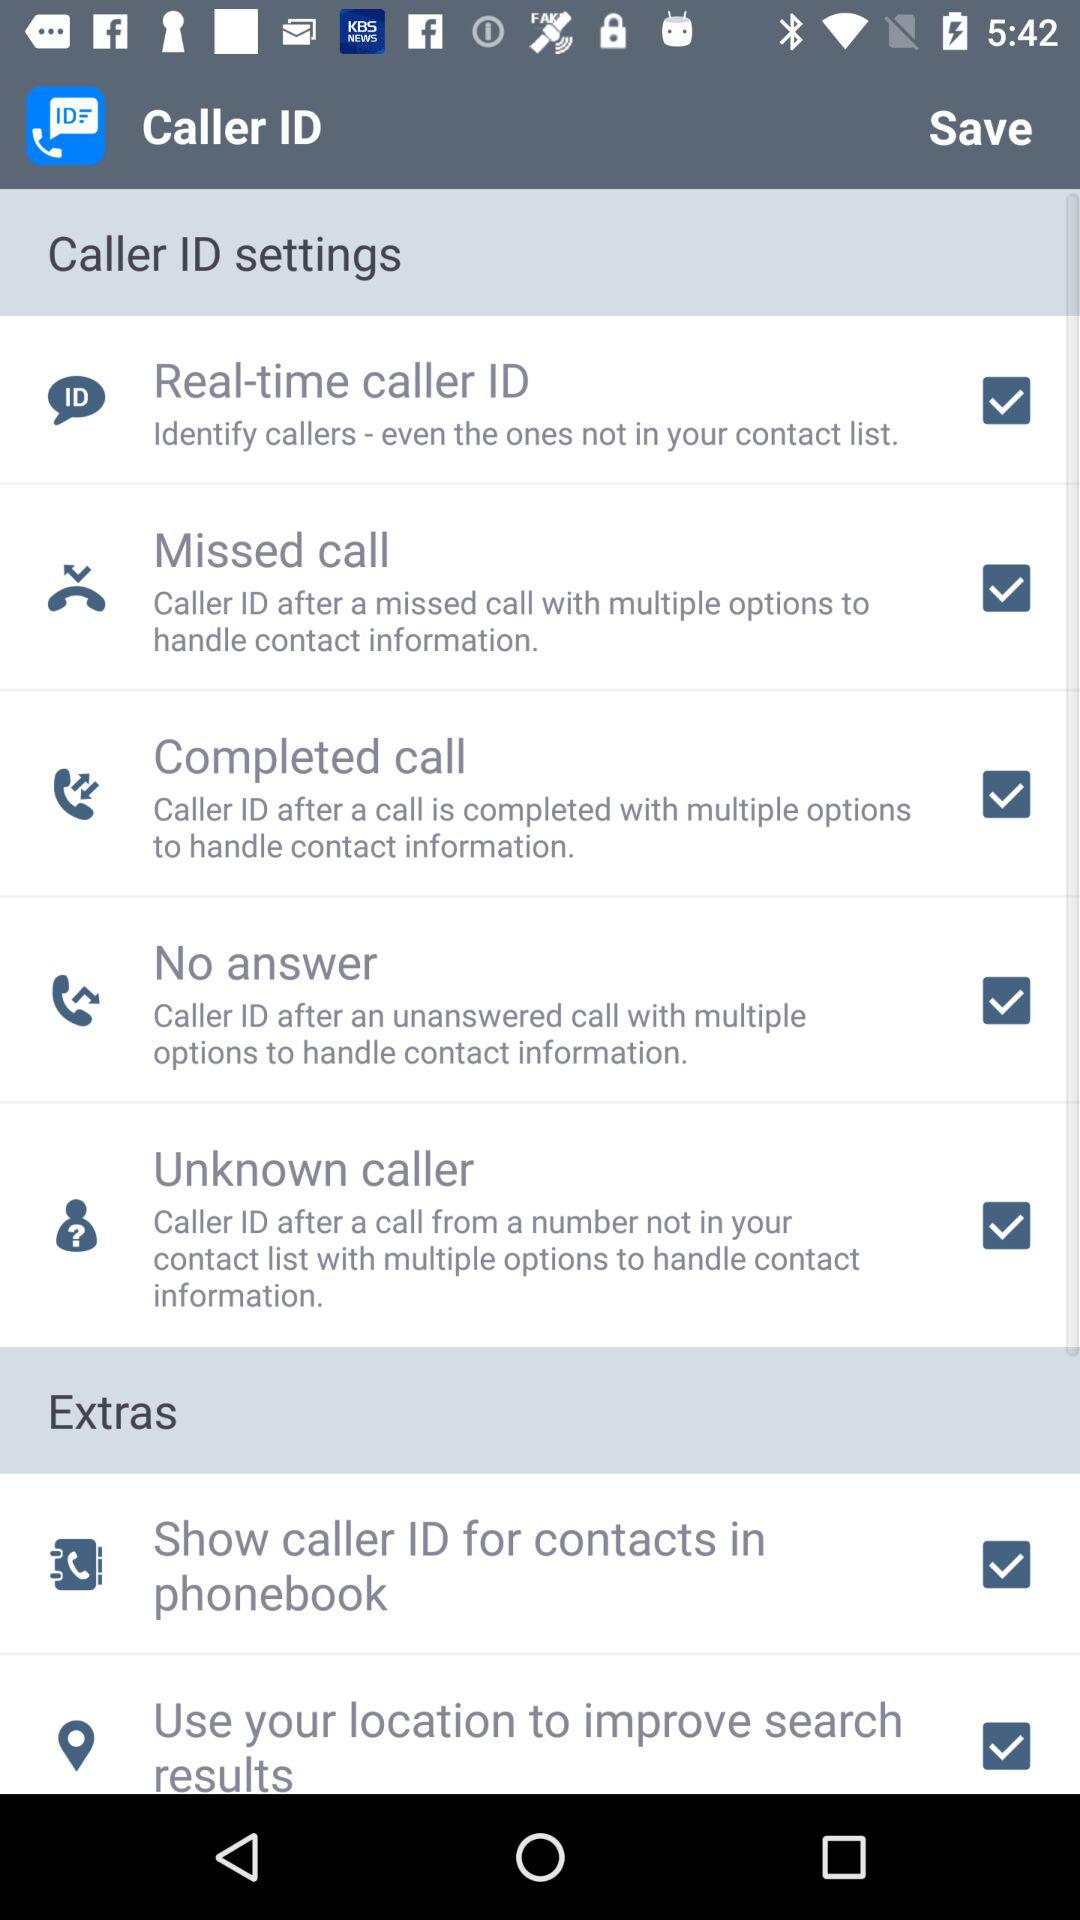What is the status of the "Missed call"? The status is "on". 